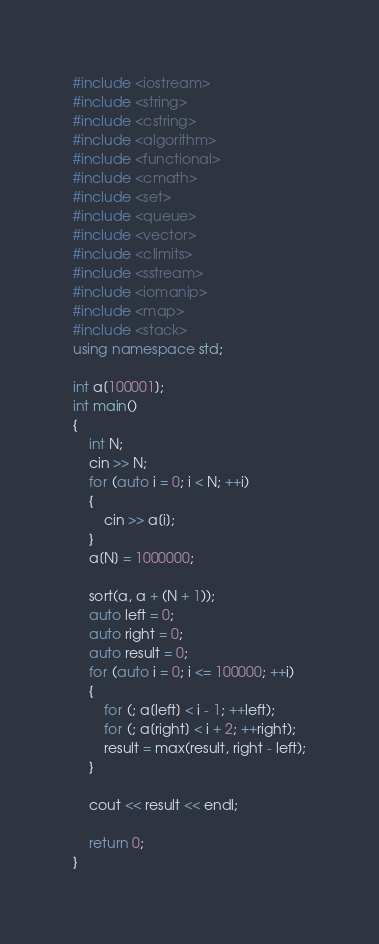Convert code to text. <code><loc_0><loc_0><loc_500><loc_500><_C++_>#include <iostream>
#include <string>
#include <cstring>
#include <algorithm>
#include <functional>
#include <cmath>
#include <set>
#include <queue>
#include <vector>
#include <climits>
#include <sstream>
#include <iomanip>
#include <map>
#include <stack>
using namespace std;

int a[100001];
int main()
{
	int N;
	cin >> N;
	for (auto i = 0; i < N; ++i)
	{
		cin >> a[i];
	}
	a[N] = 1000000;

	sort(a, a + (N + 1));
	auto left = 0;
	auto right = 0;
	auto result = 0;
	for (auto i = 0; i <= 100000; ++i)
	{
		for (; a[left] < i - 1; ++left);
		for (; a[right] < i + 2; ++right);
		result = max(result, right - left);
	}

	cout << result << endl;

	return 0;
}</code> 